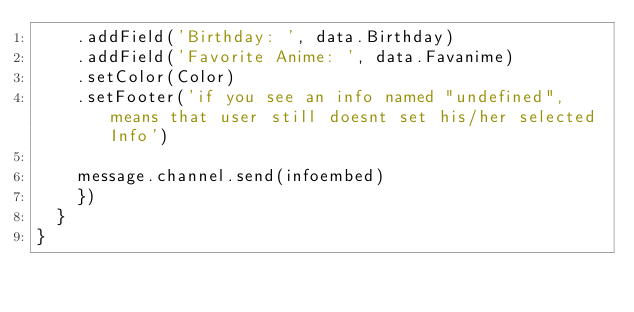<code> <loc_0><loc_0><loc_500><loc_500><_JavaScript_>    .addField('Birthday: ', data.Birthday)
    .addField('Favorite Anime: ', data.Favanime)
    .setColor(Color)
    .setFooter('if you see an info named "undefined", means that user still doesnt set his/her selected Info')
		
    message.channel.send(infoembed)
    })
  }
}</code> 